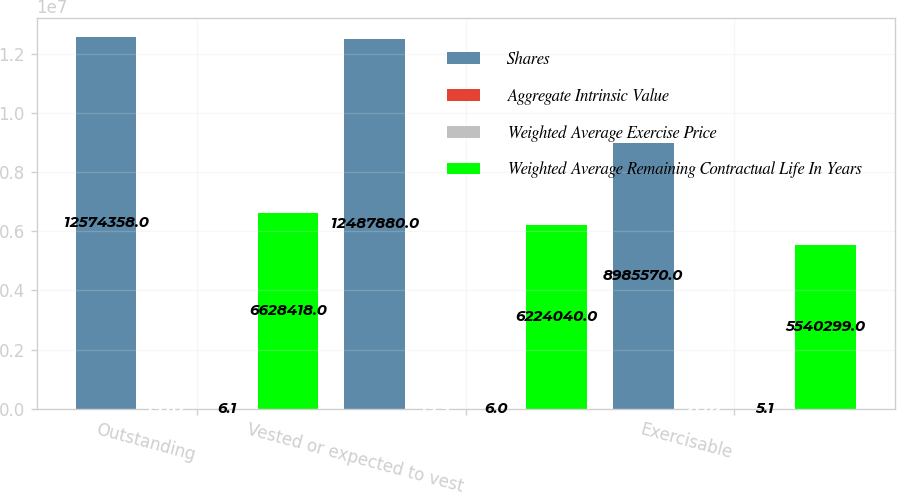Convert chart. <chart><loc_0><loc_0><loc_500><loc_500><stacked_bar_chart><ecel><fcel>Outstanding<fcel>Vested or expected to vest<fcel>Exercisable<nl><fcel>Shares<fcel>1.25744e+07<fcel>1.24879e+07<fcel>8.98557e+06<nl><fcel>Aggregate Intrinsic Value<fcel>19.87<fcel>19.9<fcel>21.02<nl><fcel>Weighted Average Exercise Price<fcel>6.1<fcel>6<fcel>5.1<nl><fcel>Weighted Average Remaining Contractual Life In Years<fcel>6.62842e+06<fcel>6.22404e+06<fcel>5.5403e+06<nl></chart> 